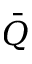<formula> <loc_0><loc_0><loc_500><loc_500>\bar { Q }</formula> 